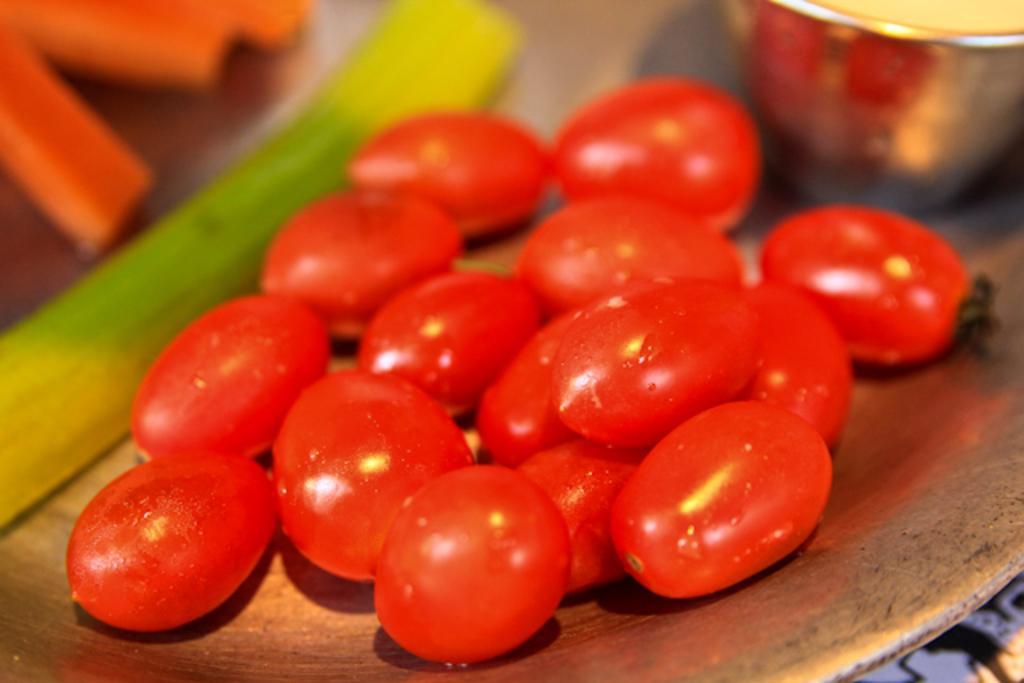Can you describe this image briefly? In this picture we can see a plate in the front, there is a glass and some fruits present in the plate, there is a blurry background. 